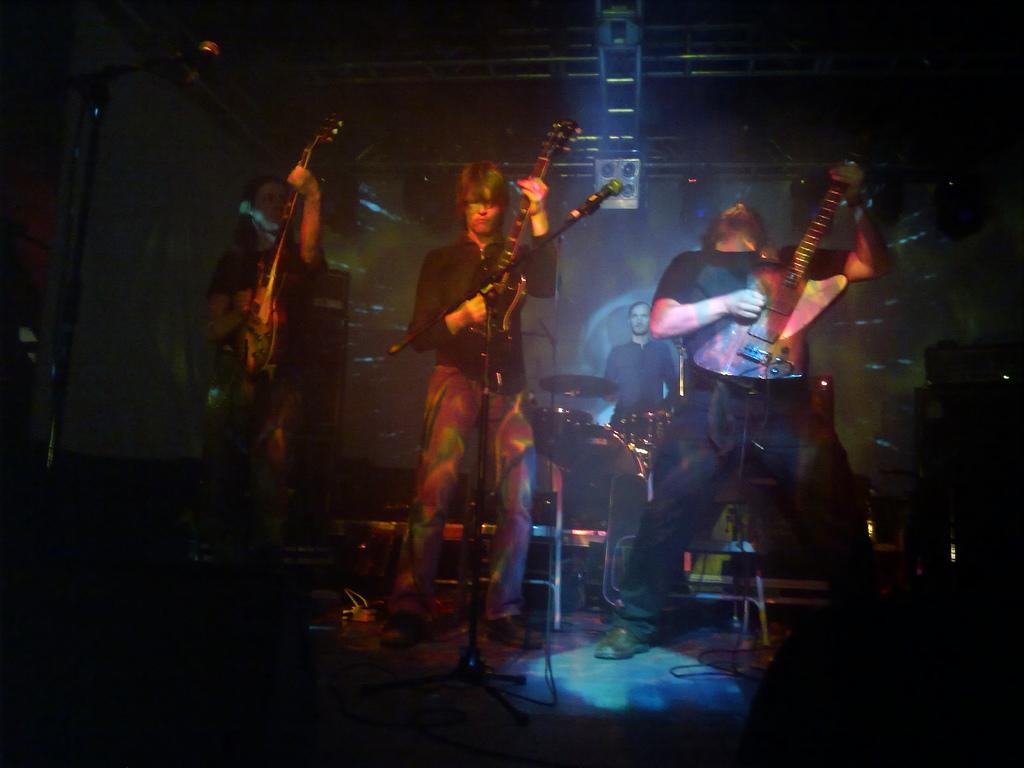How many people are in the image? There are three people in the image. What are the three people doing? The three people are standing and each is holding a guitar. Is there anyone else in the image besides the three people? Yes, there is a man in the background of the image. What is the man in the background doing? The man in the background is playing a drum set. What type of shoes is the horse wearing in the image? There is no horse present in the image, so it is not possible to determine what type of shoes it might be wearing. 